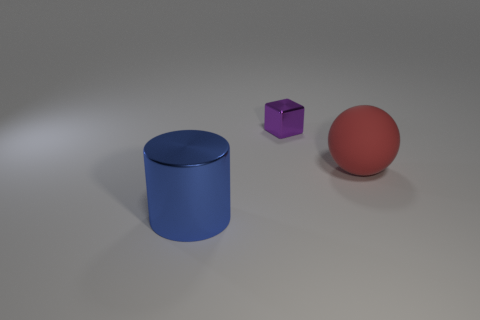Add 3 large purple cubes. How many objects exist? 6 Subtract 1 blue cylinders. How many objects are left? 2 Subtract all cylinders. How many objects are left? 2 Subtract all tiny purple metal objects. Subtract all big cyan metal things. How many objects are left? 2 Add 2 large blue shiny things. How many large blue shiny things are left? 3 Add 3 large blue shiny things. How many large blue shiny things exist? 4 